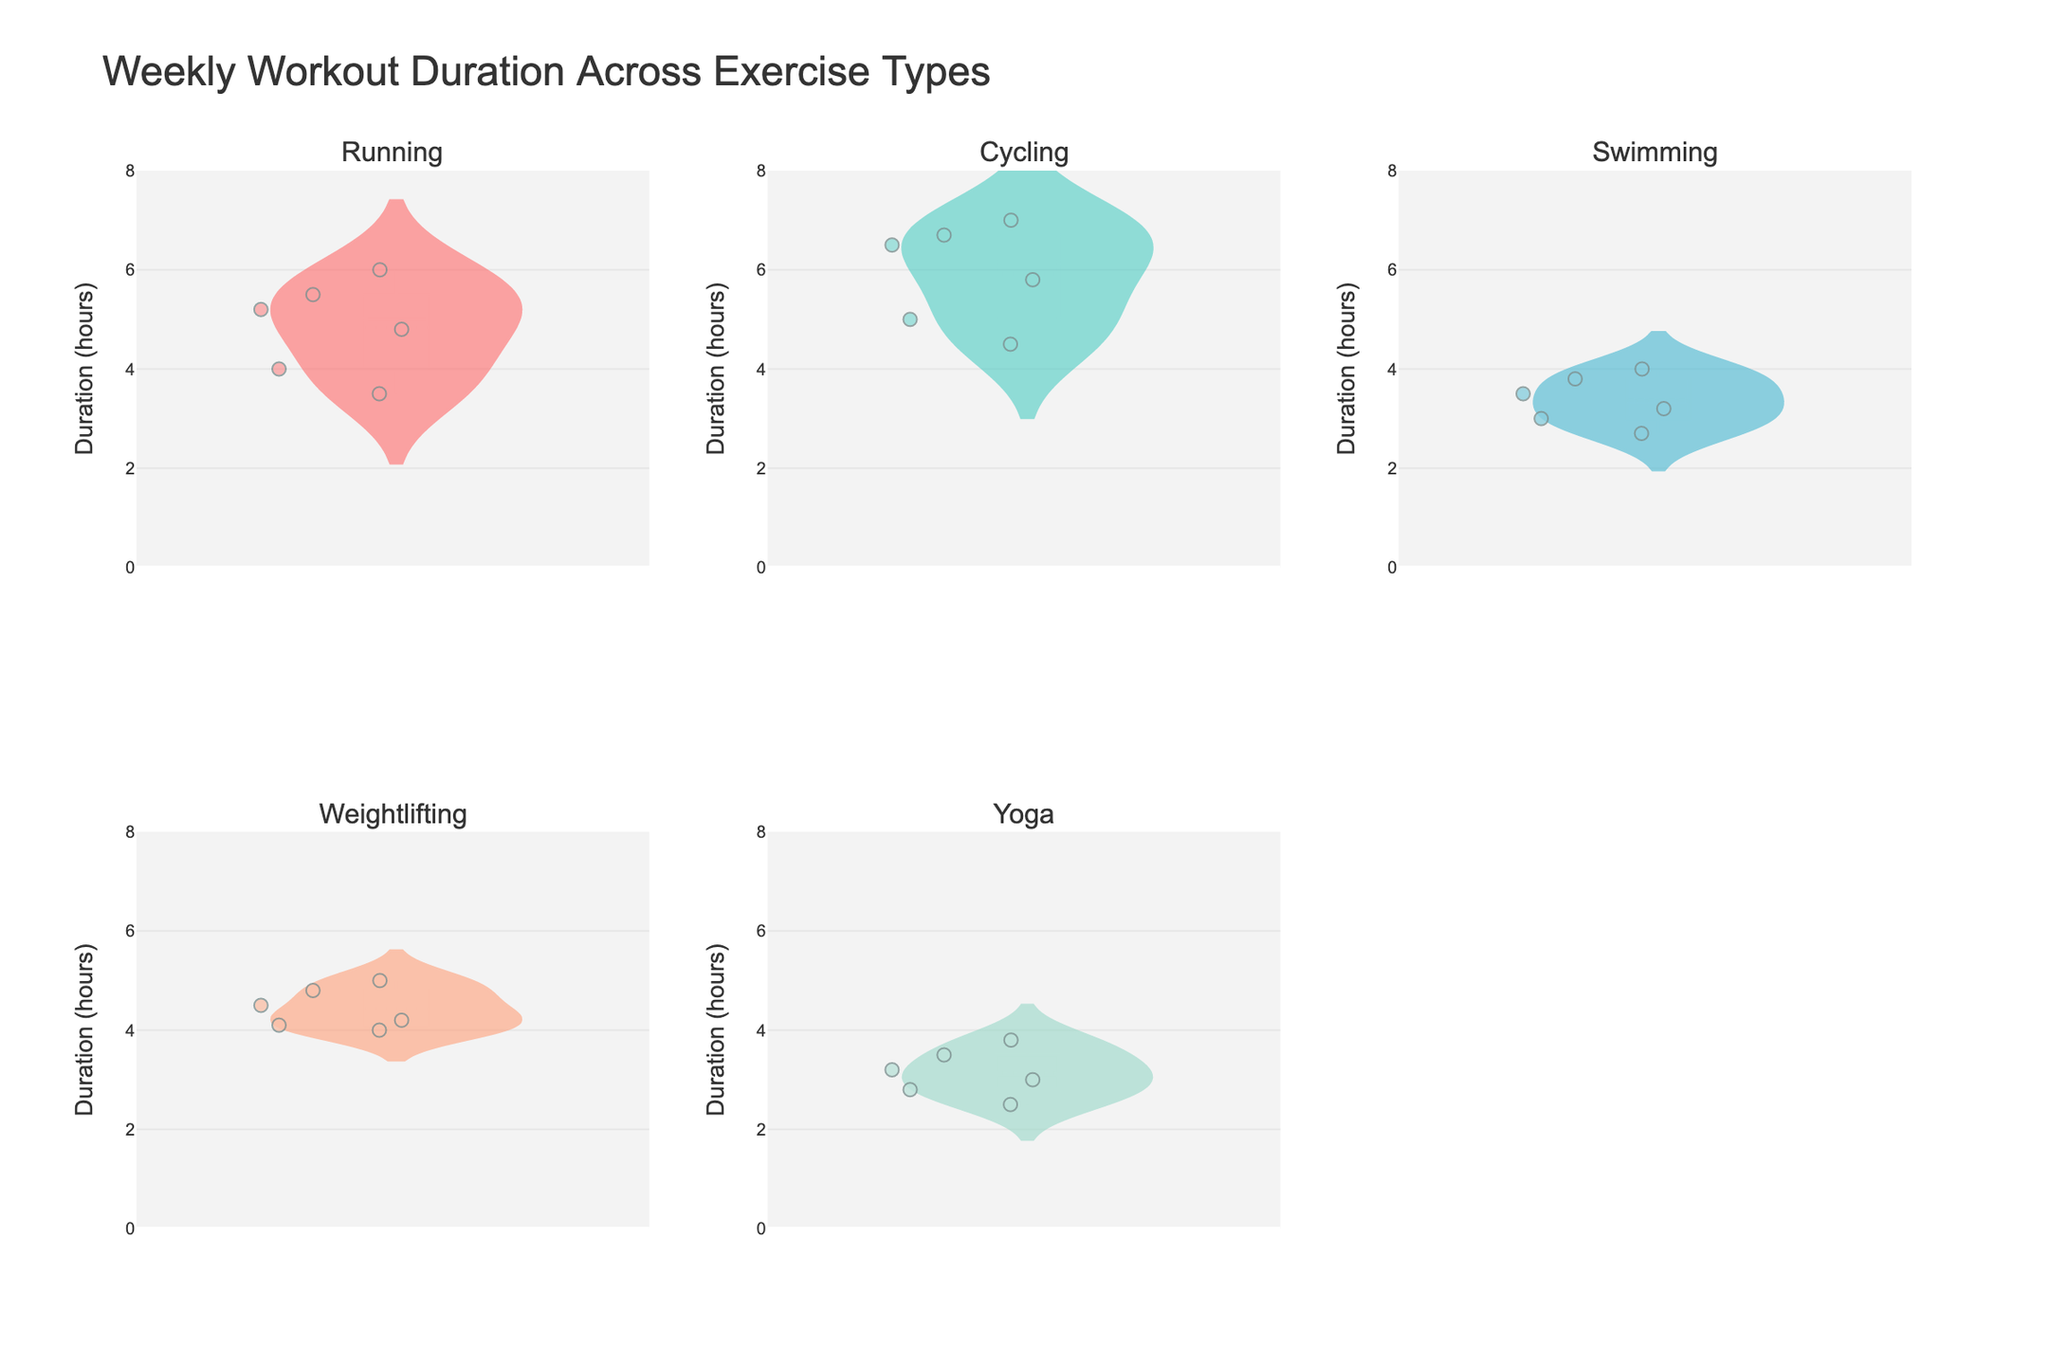What is the title of the plot? The title of the plot is displayed at the top and is prominent. It reads "Weekly Workout Duration Across Exercise Types".
Answer: Weekly Workout Duration Across Exercise Types Which exercise type appears in the top-left subplot? The top-left subplot is the first subplot and it represents the "Running" exercise type.
Answer: Running How many exercise types are displayed in total? There are a total of five exercise types displayed as each subplot corresponds to one exercise type: Running, Cycling, Swimming, Weightlifting, and Yoga.
Answer: Five What is the range of the y-axis? The y-axis range is displayed on the left of the plots and spans from 0 to 8 hours.
Answer: 0 to 8 hours What's the color used for the Cycling subplot? The color for the Cycling subplot is greenish which is represented by a shade of teal.
Answer: Teal What type of points are displayed within each violin plot? Each violin plot displays all individual data points which are represented as small markers scattered around the center line of the violin. These points add transparency to the individual value distribution alongside the violin shape.
Answer: All individual points Which exercise type has the highest median workout duration? Examining the central vertical line for the median, the "Cycling" subplot shows the highest median workout duration compared to the other exercise types.
Answer: Cycling Compare the spread of duration between "Running" and "Yoga." Which one shows more variance in duration? "Running" shows a wider spread of data points and a larger shape of the violin plot compared to "Yoga," indicating more variance in workout duration.
Answer: Running What is the approximate mean duration for Weightlifting? The mean duration is represented by a horizontal line in each violin plot. For Weightlifting, this line is approximately at 4.4 hours.
Answer: 4.4 hours Which exercise type shows the smallest difference between the minimum and maximum durations? The exercise that shows the smallest difference between the minimum and maximum durations based on the length of the violin plot is "Swimming."
Answer: Swimming 